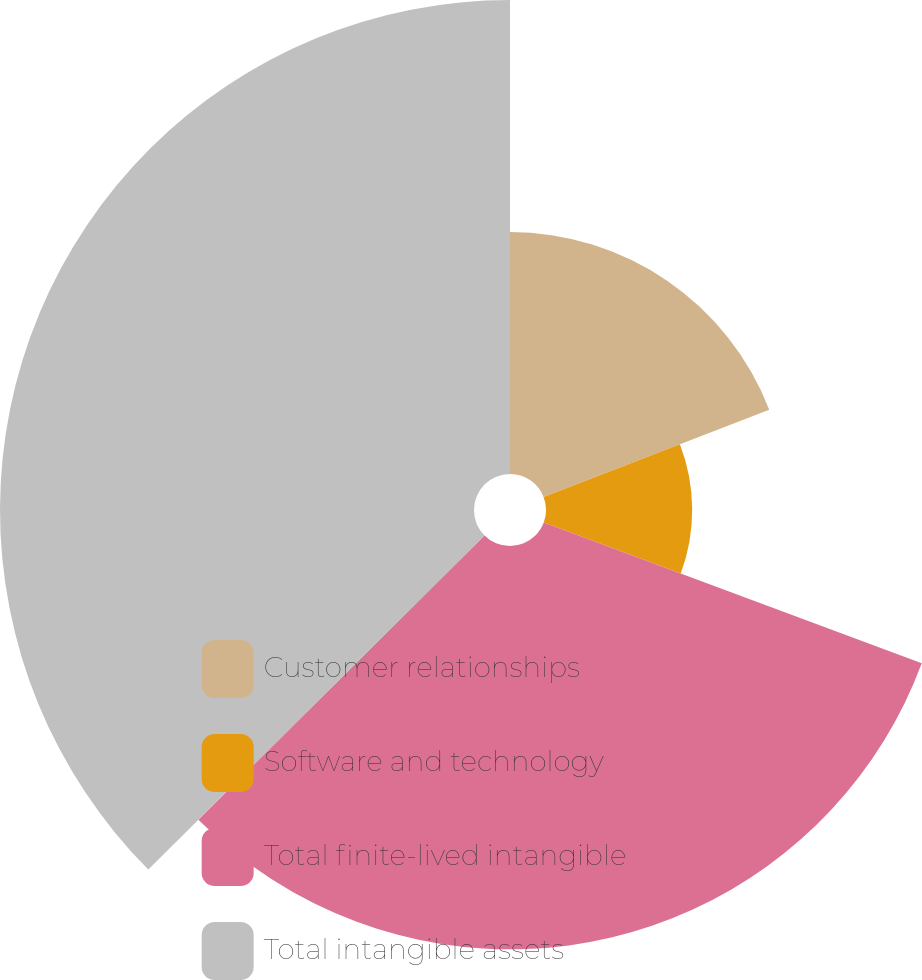Convert chart to OTSL. <chart><loc_0><loc_0><loc_500><loc_500><pie_chart><fcel>Customer relationships<fcel>Software and technology<fcel>Total finite-lived intangible<fcel>Total intangible assets<nl><fcel>19.12%<fcel>11.55%<fcel>31.87%<fcel>37.45%<nl></chart> 